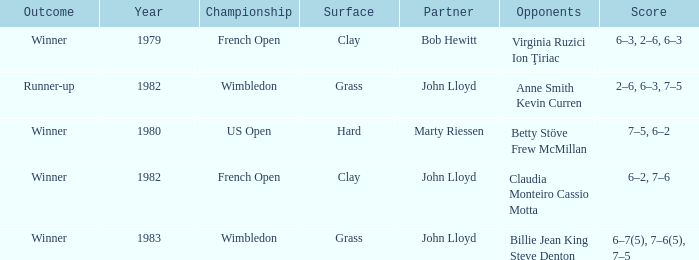Who were the opponents that led to an outcome of winner on a grass surface? Billie Jean King Steve Denton. 